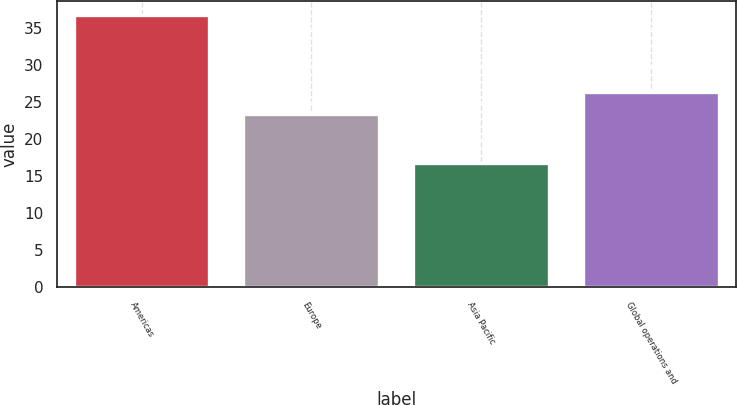Convert chart. <chart><loc_0><loc_0><loc_500><loc_500><bar_chart><fcel>Americas<fcel>Europe<fcel>Asia Pacific<fcel>Global operations and<nl><fcel>36.8<fcel>23.4<fcel>16.8<fcel>26.3<nl></chart> 